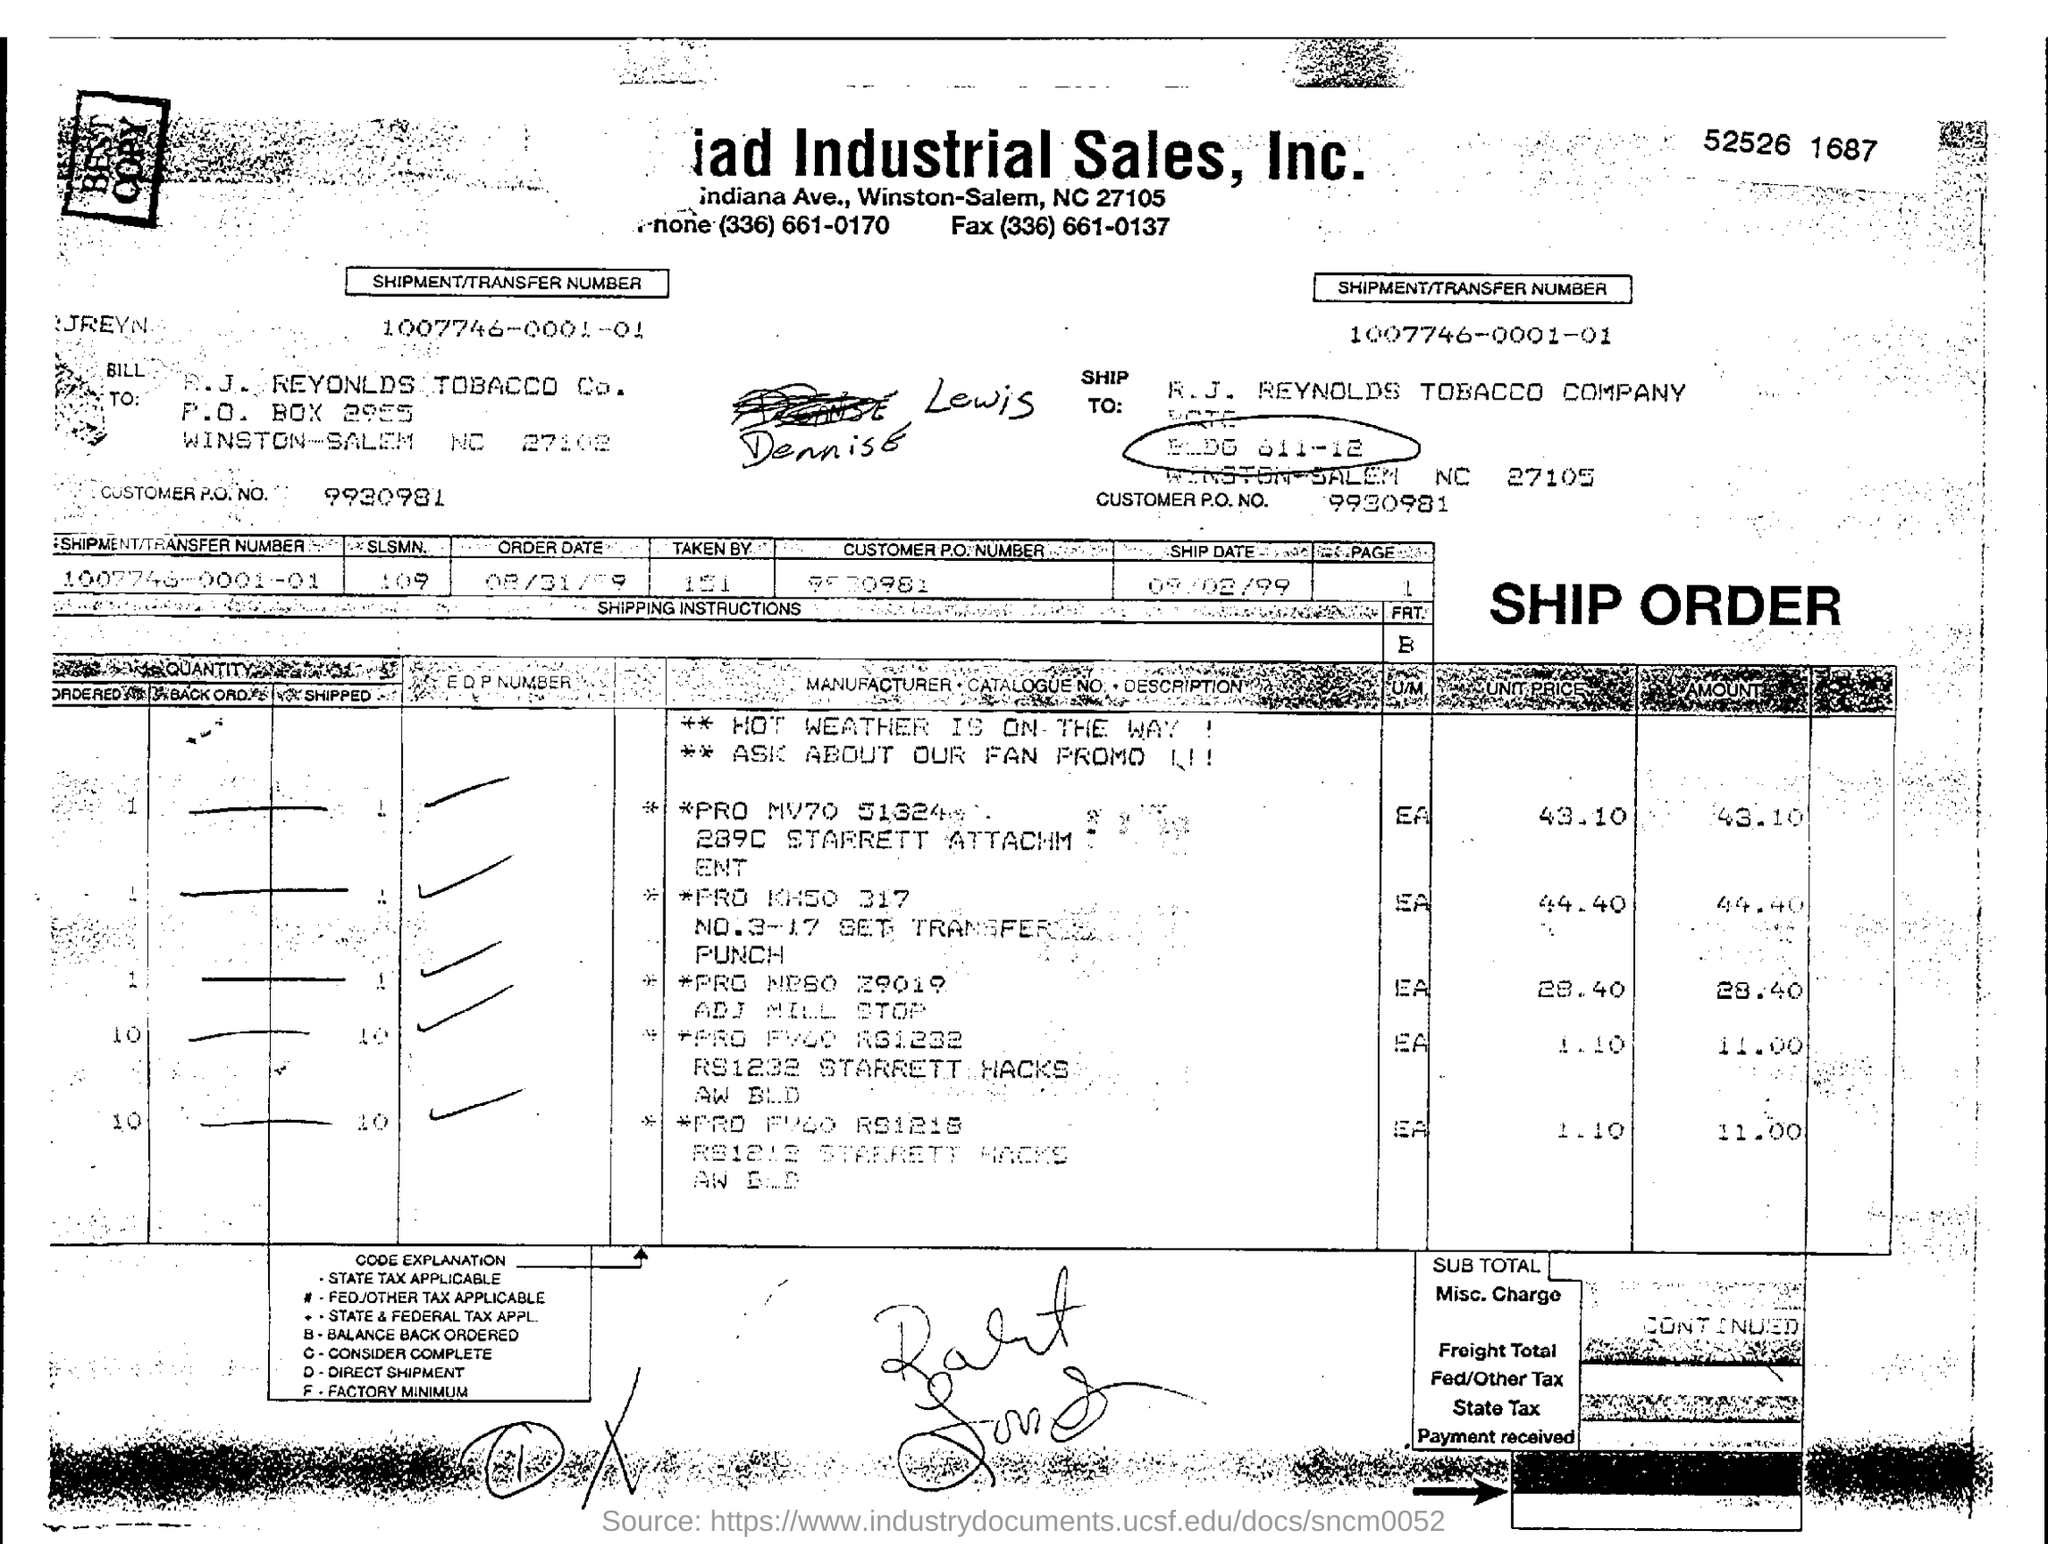Specify some key components in this picture. Can you please provide the customer purchase order number, which is 9930981... The shipment/transfer number mentioned in the document is 1007746-0001-01. The shipment is made to R. J. Reynolds Tobacco Company. 